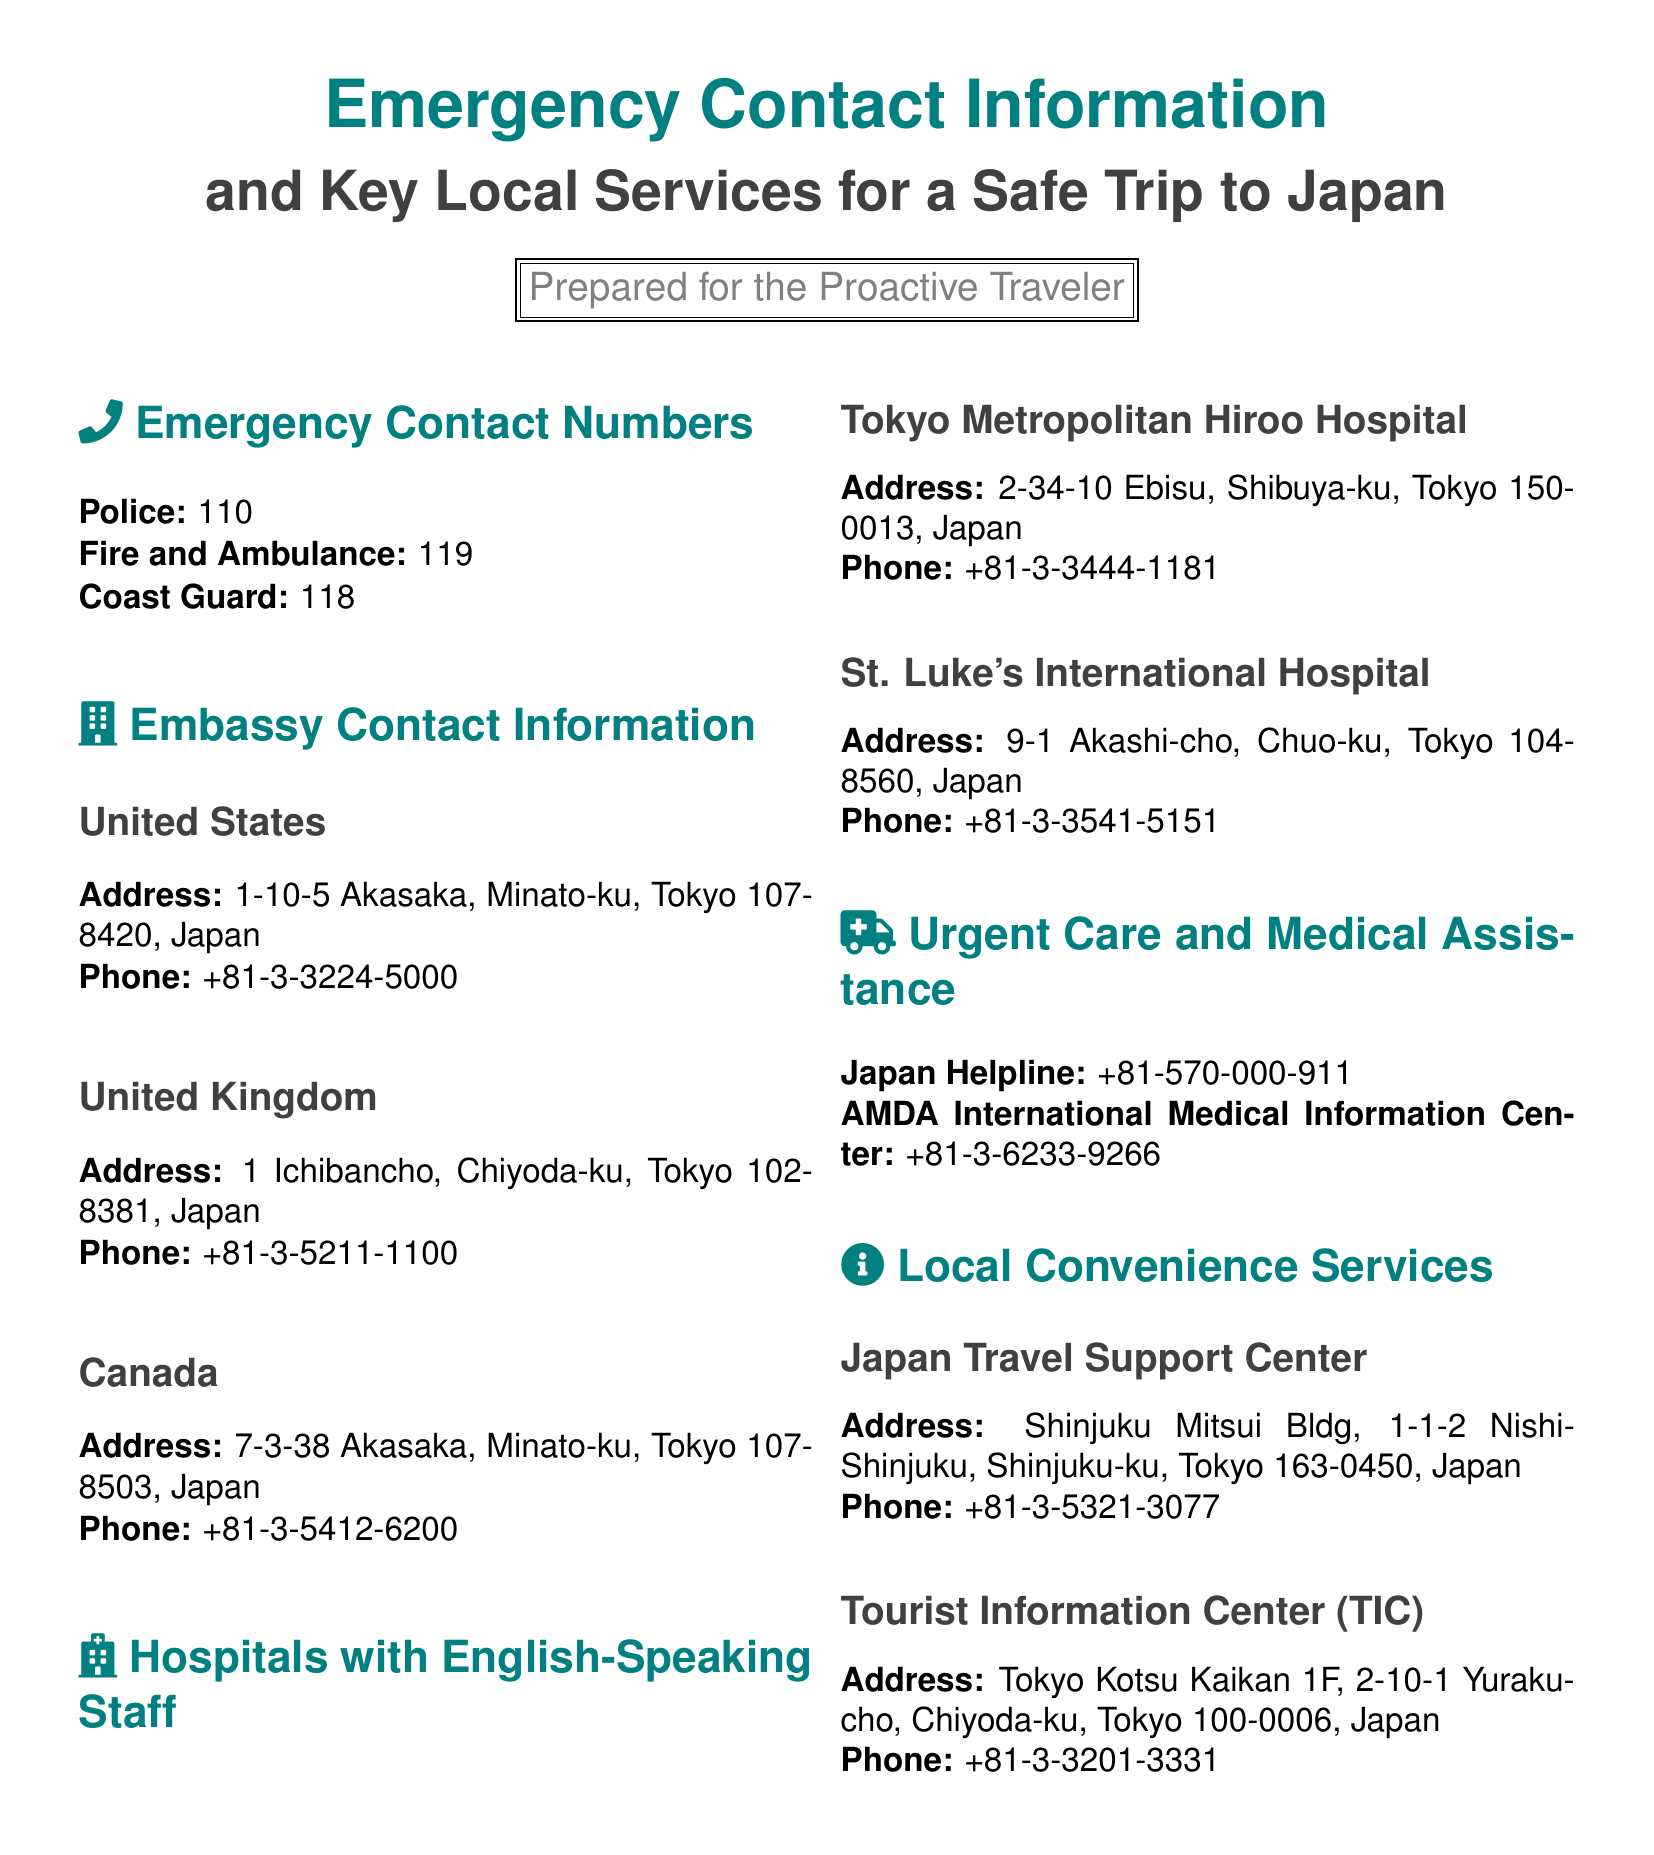What is the emergency number for police in Japan? The document specifies the emergency contact number for police is 110.
Answer: 110 What is the address of the United States Embassy in Tokyo? The address listed for the United States Embassy is 1-10-5 Akasaka, Minato-ku, Tokyo 107-8420, Japan.
Answer: 1-10-5 Akasaka, Minato-ku, Tokyo 107-8420, Japan Which hospital has English-speaking staff located in Shibuya-ku? The document states that Tokyo Metropolitan Hiroo Hospital is located in Shibuya-ku and has English-speaking staff.
Answer: Tokyo Metropolitan Hiroo Hospital What is the phone number for the Japan Helpline? The phone number provided for the Japan Helpline is +81-570-000-911.
Answer: +81-570-000-911 What is the purpose of the Japan Travel Support Center? The document indicates that it offers local convenience services for travelers.
Answer: Local convenience services What is the phone number of the Tourist Information Center? The document states the phone number for the Tourist Information Center is +81-3-3201-3331.
Answer: +81-3-3201-3331 Which city is St. Luke's International Hospital located in? The document specifies that St. Luke's International Hospital is located in Tokyo.
Answer: Tokyo How many emergency contact numbers are listed in the document? The document includes three emergency contact numbers: police, fire and ambulance, and coast guard.
Answer: Three 